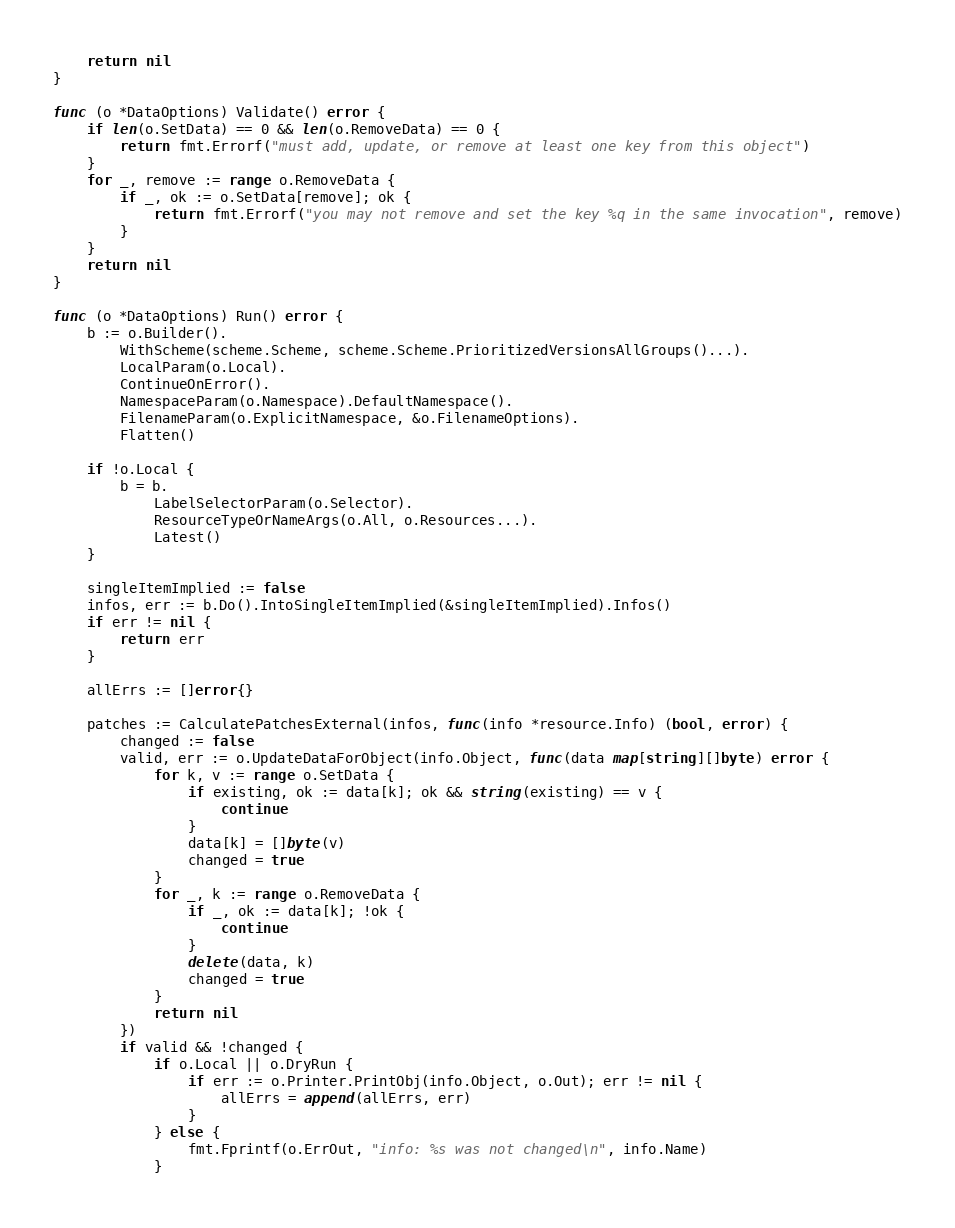<code> <loc_0><loc_0><loc_500><loc_500><_Go_>
	return nil
}

func (o *DataOptions) Validate() error {
	if len(o.SetData) == 0 && len(o.RemoveData) == 0 {
		return fmt.Errorf("must add, update, or remove at least one key from this object")
	}
	for _, remove := range o.RemoveData {
		if _, ok := o.SetData[remove]; ok {
			return fmt.Errorf("you may not remove and set the key %q in the same invocation", remove)
		}
	}
	return nil
}

func (o *DataOptions) Run() error {
	b := o.Builder().
		WithScheme(scheme.Scheme, scheme.Scheme.PrioritizedVersionsAllGroups()...).
		LocalParam(o.Local).
		ContinueOnError().
		NamespaceParam(o.Namespace).DefaultNamespace().
		FilenameParam(o.ExplicitNamespace, &o.FilenameOptions).
		Flatten()

	if !o.Local {
		b = b.
			LabelSelectorParam(o.Selector).
			ResourceTypeOrNameArgs(o.All, o.Resources...).
			Latest()
	}

	singleItemImplied := false
	infos, err := b.Do().IntoSingleItemImplied(&singleItemImplied).Infos()
	if err != nil {
		return err
	}

	allErrs := []error{}

	patches := CalculatePatchesExternal(infos, func(info *resource.Info) (bool, error) {
		changed := false
		valid, err := o.UpdateDataForObject(info.Object, func(data map[string][]byte) error {
			for k, v := range o.SetData {
				if existing, ok := data[k]; ok && string(existing) == v {
					continue
				}
				data[k] = []byte(v)
				changed = true
			}
			for _, k := range o.RemoveData {
				if _, ok := data[k]; !ok {
					continue
				}
				delete(data, k)
				changed = true
			}
			return nil
		})
		if valid && !changed {
			if o.Local || o.DryRun {
				if err := o.Printer.PrintObj(info.Object, o.Out); err != nil {
					allErrs = append(allErrs, err)
				}
			} else {
				fmt.Fprintf(o.ErrOut, "info: %s was not changed\n", info.Name)
			}</code> 